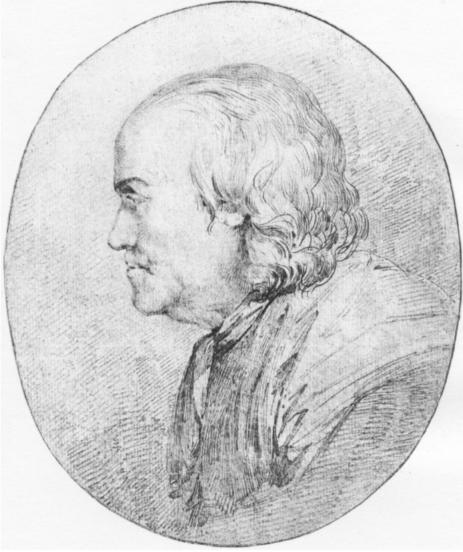Write a detailed description of the given image. The image is a finely detailed black and white sketch of a man portrayed in profile, facing left. He is dressed in a distinctly styled coat with a high, ornate collar, suggesting a historical period possibly in the 18th or 19th century. His hair is styled backward, adhering to period fashion, and his facial features are rendered with precise, delicate strokes, emphasizing sharp contours and serene expression. The medium of sketching, along with the oval frame, conjures a sense of viewing an important historical document, preserving the dignity and decorum of the person depicted. The background is intentionally plain, focusing all attention on the intricate details of the man's visage and attire. The artistry displayed suggests a skilled hand, capturing not just a likeness but a mood, possibly hinting at the subject's social status or personality. 